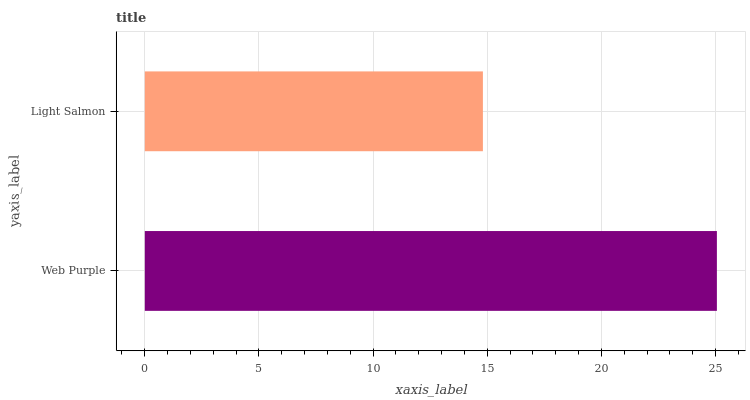Is Light Salmon the minimum?
Answer yes or no. Yes. Is Web Purple the maximum?
Answer yes or no. Yes. Is Light Salmon the maximum?
Answer yes or no. No. Is Web Purple greater than Light Salmon?
Answer yes or no. Yes. Is Light Salmon less than Web Purple?
Answer yes or no. Yes. Is Light Salmon greater than Web Purple?
Answer yes or no. No. Is Web Purple less than Light Salmon?
Answer yes or no. No. Is Web Purple the high median?
Answer yes or no. Yes. Is Light Salmon the low median?
Answer yes or no. Yes. Is Light Salmon the high median?
Answer yes or no. No. Is Web Purple the low median?
Answer yes or no. No. 